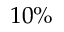<formula> <loc_0><loc_0><loc_500><loc_500>1 0 \%</formula> 